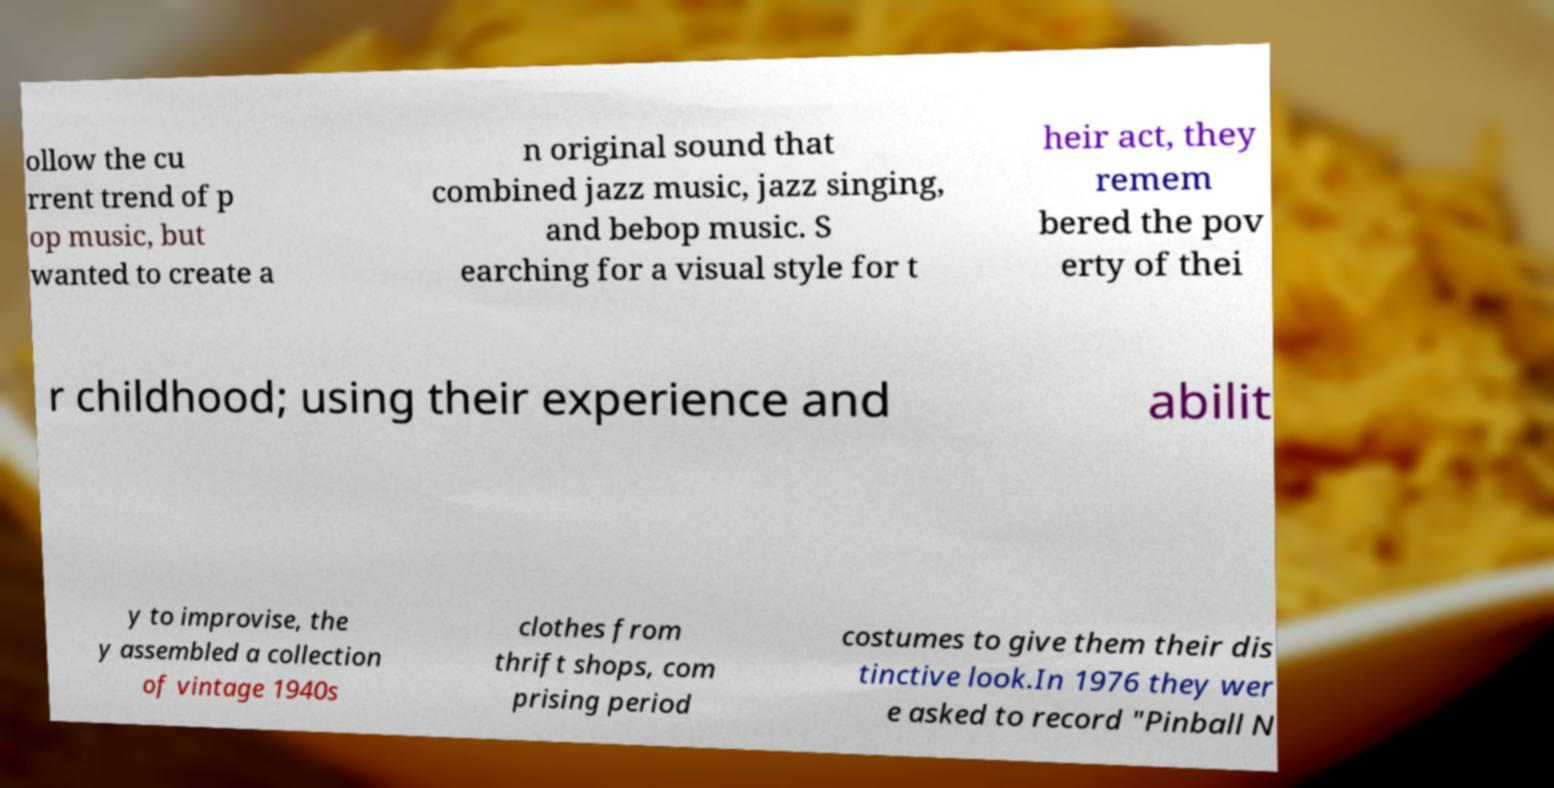For documentation purposes, I need the text within this image transcribed. Could you provide that? ollow the cu rrent trend of p op music, but wanted to create a n original sound that combined jazz music, jazz singing, and bebop music. S earching for a visual style for t heir act, they remem bered the pov erty of thei r childhood; using their experience and abilit y to improvise, the y assembled a collection of vintage 1940s clothes from thrift shops, com prising period costumes to give them their dis tinctive look.In 1976 they wer e asked to record "Pinball N 